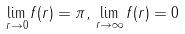<formula> <loc_0><loc_0><loc_500><loc_500>\lim _ { r \rightarrow 0 } f ( r ) = \pi , \, \lim _ { r \rightarrow \infty } f ( r ) = 0</formula> 